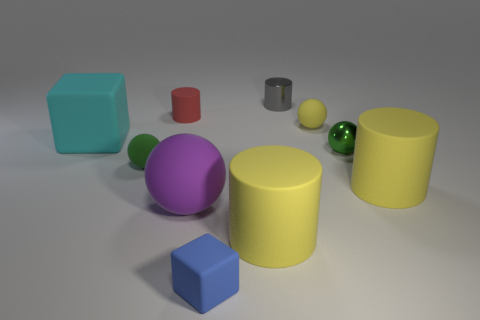Subtract all rubber cylinders. How many cylinders are left? 1 Subtract 3 cylinders. How many cylinders are left? 1 Subtract all cubes. How many objects are left? 8 Subtract all yellow balls. How many balls are left? 3 Subtract all brown cylinders. Subtract all red blocks. How many cylinders are left? 4 Subtract all cyan spheres. How many gray cylinders are left? 1 Subtract all large cyan rubber cylinders. Subtract all big yellow cylinders. How many objects are left? 8 Add 1 tiny rubber blocks. How many tiny rubber blocks are left? 2 Add 4 green shiny spheres. How many green shiny spheres exist? 5 Subtract 2 yellow cylinders. How many objects are left? 8 